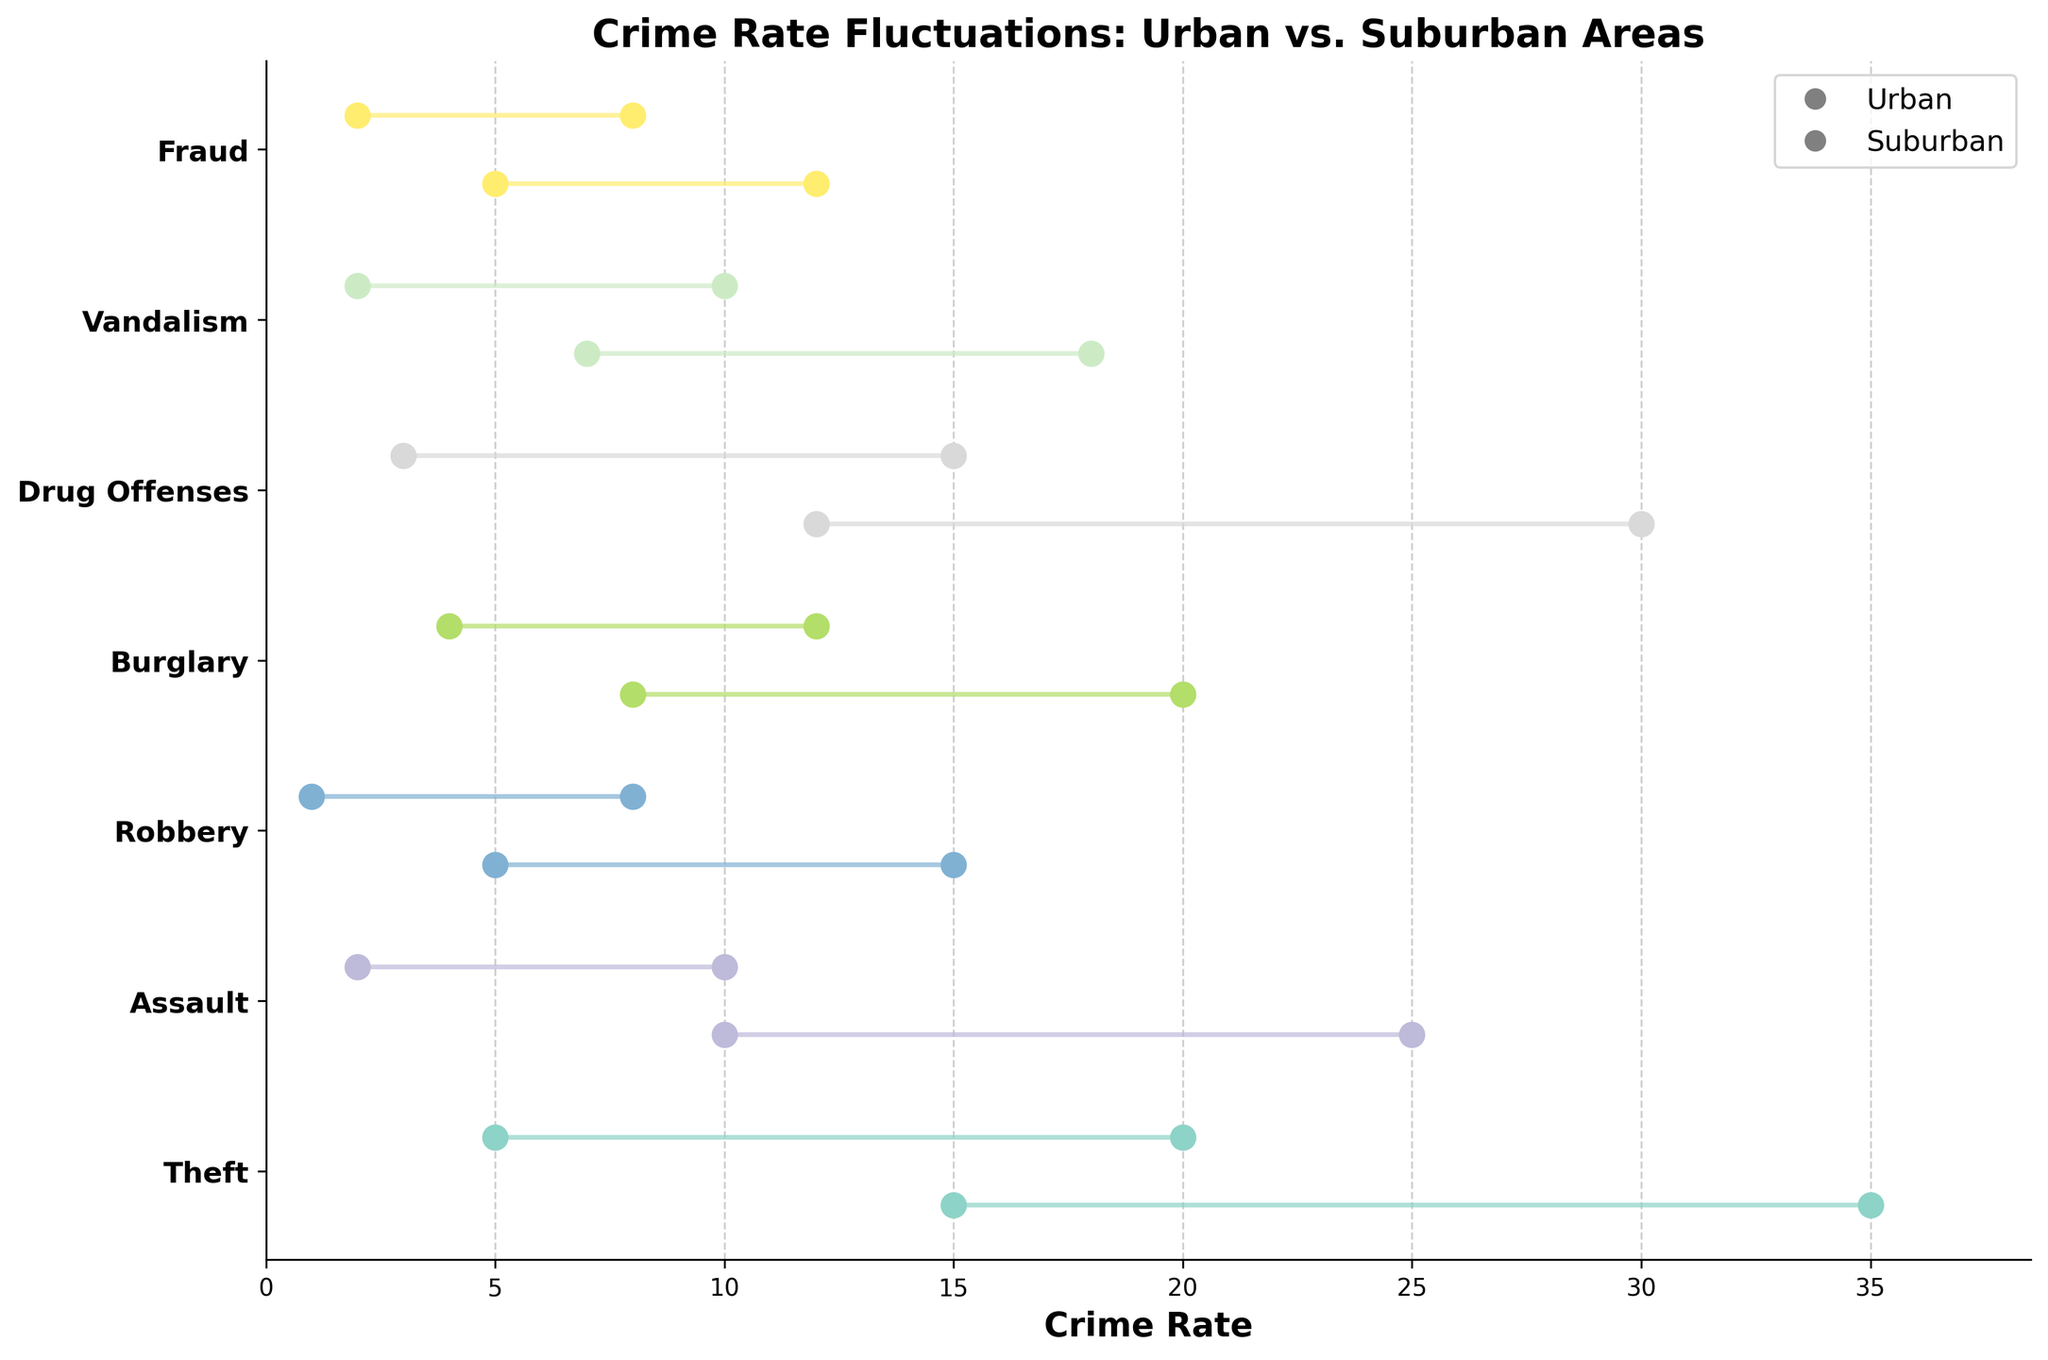What is the title of the figure? The title of the figure is placed at the top and usually summarizes the main topic or finding that the figure is addressing. In this case, it denotes the comparison of crime rate fluctuations between two areas.
Answer: Crime Rate Fluctuations: Urban vs. Suburban Areas Which crime type shows the smallest minimum rate in urban areas? By looking at the minimum rate values on the x-axis for each crime type in the urban category, we can spot the smallest value. Here, 'Fraud' has the smallest minimum rate, which is 5.
Answer: Fraud Which area has a higher maximum rate for 'Drug Offenses'? The maximum rate for 'Drug Offenses' in urban areas is 30, while in suburban areas it is 15. Comparatively, urban areas have a higher maximum rate.
Answer: Urban Which crime type has the most similar range in both urban and suburban areas? By comparing the ranges (calculated as max rate minus min rate) for each crime type across both areas, 'Vandalism' appears to have the most similar range. In urban areas, the range is 18 - 7 = 11, and in suburban areas, it is 10 - 2 = 8. The ranges are close to each other.
Answer: Vandalism Which crime types have a minimum rate of more than 10 in urban areas? Observing the minimum rates, 'Theft' and 'Drug Offenses' are the crime types in urban areas with a minimum rate greater than 10.
Answer: Theft, Drug Offenses Which area has a lower minimum rate for 'Burglary'? The minimum rate for 'Burglary' in urban areas is 8, and in suburban areas, it is 4. The suburban area has a lower minimum rate.
Answer: Suburban 